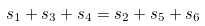Convert formula to latex. <formula><loc_0><loc_0><loc_500><loc_500>s _ { 1 } + s _ { 3 } + s _ { 4 } = s _ { 2 } + s _ { 5 } + s _ { 6 }</formula> 